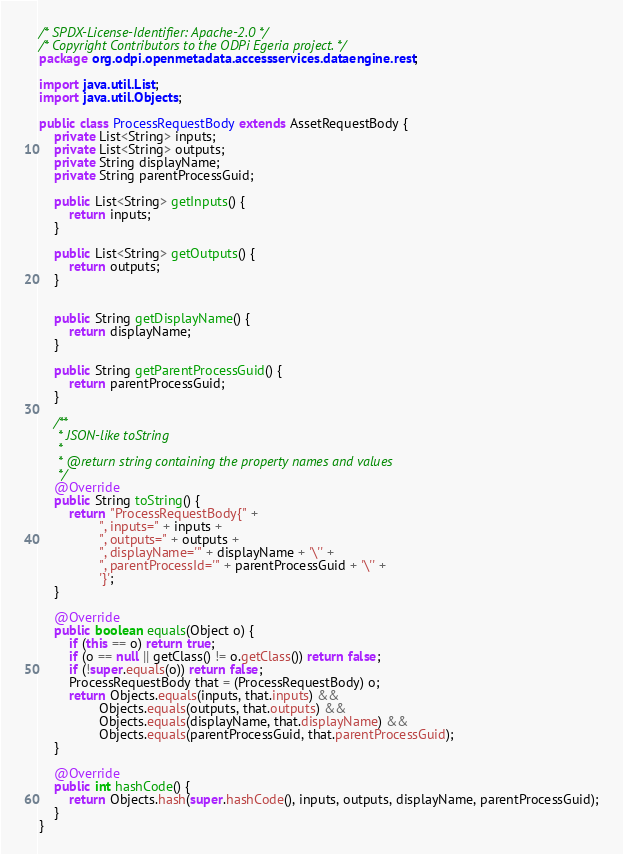<code> <loc_0><loc_0><loc_500><loc_500><_Java_>/* SPDX-License-Identifier: Apache-2.0 */
/* Copyright Contributors to the ODPi Egeria project. */
package org.odpi.openmetadata.accessservices.dataengine.rest;

import java.util.List;
import java.util.Objects;

public class ProcessRequestBody extends AssetRequestBody {
    private List<String> inputs;
    private List<String> outputs;
    private String displayName;
    private String parentProcessGuid;

    public List<String> getInputs() {
        return inputs;
    }

    public List<String> getOutputs() {
        return outputs;
    }


    public String getDisplayName() {
        return displayName;
    }

    public String getParentProcessGuid() {
        return parentProcessGuid;
    }

    /**
     * JSON-like toString
     *
     * @return string containing the property names and values
     */
    @Override
    public String toString() {
        return "ProcessRequestBody{" +
                ", inputs=" + inputs +
                ", outputs=" + outputs +
                ", displayName='" + displayName + '\'' +
                ", parentProcessId='" + parentProcessGuid + '\'' +
                '}';
    }

    @Override
    public boolean equals(Object o) {
        if (this == o) return true;
        if (o == null || getClass() != o.getClass()) return false;
        if (!super.equals(o)) return false;
        ProcessRequestBody that = (ProcessRequestBody) o;
        return Objects.equals(inputs, that.inputs) &&
                Objects.equals(outputs, that.outputs) &&
                Objects.equals(displayName, that.displayName) &&
                Objects.equals(parentProcessGuid, that.parentProcessGuid);
    }

    @Override
    public int hashCode() {
        return Objects.hash(super.hashCode(), inputs, outputs, displayName, parentProcessGuid);
    }
}

</code> 